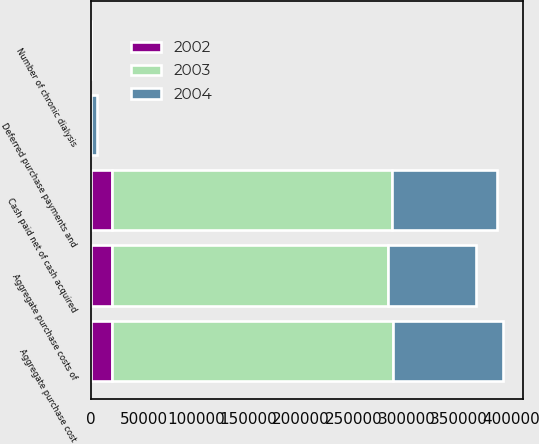Convert chart to OTSL. <chart><loc_0><loc_0><loc_500><loc_500><stacked_bar_chart><ecel><fcel>Cash paid net of cash acquired<fcel>Deferred purchase payments and<fcel>Aggregate purchase cost<fcel>Number of chronic dialysis<fcel>Aggregate purchase costs of<nl><fcel>2003<fcel>266265<fcel>429<fcel>266694<fcel>51<fcel>262458<nl><fcel>2004<fcel>99645<fcel>5146<fcel>104791<fcel>27<fcel>84102<nl><fcel>2002<fcel>19977<fcel>100<fcel>20077<fcel>11<fcel>20077<nl></chart> 